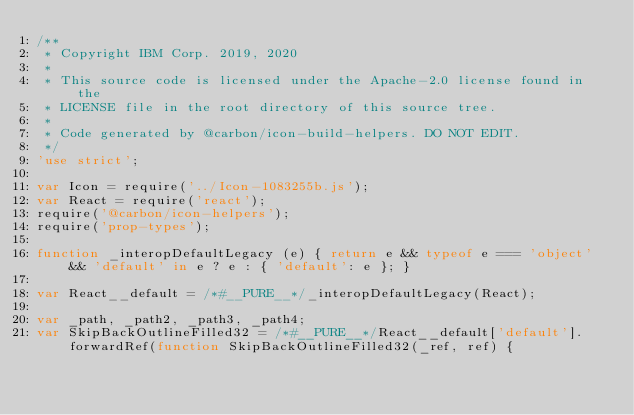<code> <loc_0><loc_0><loc_500><loc_500><_JavaScript_>/**
 * Copyright IBM Corp. 2019, 2020
 *
 * This source code is licensed under the Apache-2.0 license found in the
 * LICENSE file in the root directory of this source tree.
 *
 * Code generated by @carbon/icon-build-helpers. DO NOT EDIT.
 */
'use strict';

var Icon = require('../Icon-1083255b.js');
var React = require('react');
require('@carbon/icon-helpers');
require('prop-types');

function _interopDefaultLegacy (e) { return e && typeof e === 'object' && 'default' in e ? e : { 'default': e }; }

var React__default = /*#__PURE__*/_interopDefaultLegacy(React);

var _path, _path2, _path3, _path4;
var SkipBackOutlineFilled32 = /*#__PURE__*/React__default['default'].forwardRef(function SkipBackOutlineFilled32(_ref, ref) {</code> 